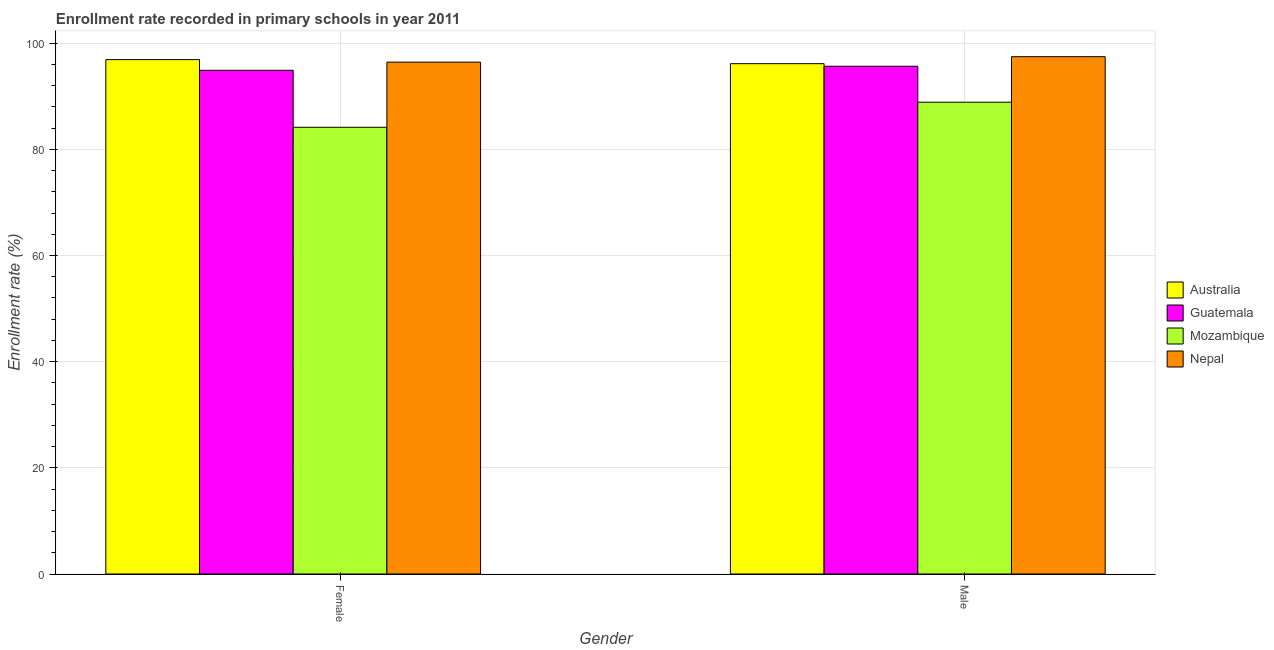How many different coloured bars are there?
Your answer should be compact. 4. How many groups of bars are there?
Provide a short and direct response. 2. How many bars are there on the 1st tick from the left?
Your answer should be compact. 4. How many bars are there on the 1st tick from the right?
Your answer should be very brief. 4. What is the enrollment rate of male students in Australia?
Ensure brevity in your answer.  96.13. Across all countries, what is the maximum enrollment rate of male students?
Your answer should be very brief. 97.45. Across all countries, what is the minimum enrollment rate of male students?
Make the answer very short. 88.87. In which country was the enrollment rate of female students minimum?
Your response must be concise. Mozambique. What is the total enrollment rate of female students in the graph?
Provide a succinct answer. 372.35. What is the difference between the enrollment rate of female students in Guatemala and that in Australia?
Give a very brief answer. -2.01. What is the difference between the enrollment rate of male students in Australia and the enrollment rate of female students in Guatemala?
Keep it short and to the point. 1.25. What is the average enrollment rate of female students per country?
Make the answer very short. 93.09. What is the difference between the enrollment rate of male students and enrollment rate of female students in Nepal?
Provide a short and direct response. 1.02. In how many countries, is the enrollment rate of male students greater than 12 %?
Make the answer very short. 4. What is the ratio of the enrollment rate of female students in Mozambique to that in Guatemala?
Make the answer very short. 0.89. Is the enrollment rate of male students in Nepal less than that in Australia?
Ensure brevity in your answer.  No. What does the 4th bar from the right in Female represents?
Offer a terse response. Australia. How many bars are there?
Your answer should be very brief. 8. Are all the bars in the graph horizontal?
Provide a short and direct response. No. How many countries are there in the graph?
Your answer should be very brief. 4. Does the graph contain grids?
Offer a terse response. Yes. Where does the legend appear in the graph?
Your answer should be very brief. Center right. What is the title of the graph?
Provide a short and direct response. Enrollment rate recorded in primary schools in year 2011. What is the label or title of the Y-axis?
Give a very brief answer. Enrollment rate (%). What is the Enrollment rate (%) in Australia in Female?
Your answer should be compact. 96.89. What is the Enrollment rate (%) in Guatemala in Female?
Offer a terse response. 94.88. What is the Enrollment rate (%) of Mozambique in Female?
Ensure brevity in your answer.  84.15. What is the Enrollment rate (%) in Nepal in Female?
Offer a very short reply. 96.42. What is the Enrollment rate (%) in Australia in Male?
Your answer should be compact. 96.13. What is the Enrollment rate (%) of Guatemala in Male?
Your response must be concise. 95.64. What is the Enrollment rate (%) in Mozambique in Male?
Provide a short and direct response. 88.87. What is the Enrollment rate (%) in Nepal in Male?
Give a very brief answer. 97.45. Across all Gender, what is the maximum Enrollment rate (%) in Australia?
Your answer should be compact. 96.89. Across all Gender, what is the maximum Enrollment rate (%) in Guatemala?
Your response must be concise. 95.64. Across all Gender, what is the maximum Enrollment rate (%) of Mozambique?
Provide a succinct answer. 88.87. Across all Gender, what is the maximum Enrollment rate (%) of Nepal?
Ensure brevity in your answer.  97.45. Across all Gender, what is the minimum Enrollment rate (%) in Australia?
Provide a succinct answer. 96.13. Across all Gender, what is the minimum Enrollment rate (%) in Guatemala?
Provide a short and direct response. 94.88. Across all Gender, what is the minimum Enrollment rate (%) of Mozambique?
Provide a succinct answer. 84.15. Across all Gender, what is the minimum Enrollment rate (%) of Nepal?
Your answer should be compact. 96.42. What is the total Enrollment rate (%) in Australia in the graph?
Your answer should be compact. 193.02. What is the total Enrollment rate (%) in Guatemala in the graph?
Ensure brevity in your answer.  190.53. What is the total Enrollment rate (%) in Mozambique in the graph?
Offer a very short reply. 173.02. What is the total Enrollment rate (%) of Nepal in the graph?
Your response must be concise. 193.87. What is the difference between the Enrollment rate (%) of Australia in Female and that in Male?
Give a very brief answer. 0.76. What is the difference between the Enrollment rate (%) in Guatemala in Female and that in Male?
Make the answer very short. -0.76. What is the difference between the Enrollment rate (%) of Mozambique in Female and that in Male?
Offer a terse response. -4.72. What is the difference between the Enrollment rate (%) of Nepal in Female and that in Male?
Keep it short and to the point. -1.02. What is the difference between the Enrollment rate (%) in Australia in Female and the Enrollment rate (%) in Guatemala in Male?
Your response must be concise. 1.25. What is the difference between the Enrollment rate (%) in Australia in Female and the Enrollment rate (%) in Mozambique in Male?
Offer a very short reply. 8.02. What is the difference between the Enrollment rate (%) in Australia in Female and the Enrollment rate (%) in Nepal in Male?
Give a very brief answer. -0.55. What is the difference between the Enrollment rate (%) of Guatemala in Female and the Enrollment rate (%) of Mozambique in Male?
Offer a very short reply. 6.01. What is the difference between the Enrollment rate (%) in Guatemala in Female and the Enrollment rate (%) in Nepal in Male?
Ensure brevity in your answer.  -2.56. What is the difference between the Enrollment rate (%) of Mozambique in Female and the Enrollment rate (%) of Nepal in Male?
Ensure brevity in your answer.  -13.3. What is the average Enrollment rate (%) of Australia per Gender?
Provide a short and direct response. 96.51. What is the average Enrollment rate (%) of Guatemala per Gender?
Provide a short and direct response. 95.26. What is the average Enrollment rate (%) in Mozambique per Gender?
Provide a succinct answer. 86.51. What is the average Enrollment rate (%) of Nepal per Gender?
Your response must be concise. 96.93. What is the difference between the Enrollment rate (%) of Australia and Enrollment rate (%) of Guatemala in Female?
Provide a succinct answer. 2.01. What is the difference between the Enrollment rate (%) in Australia and Enrollment rate (%) in Mozambique in Female?
Ensure brevity in your answer.  12.74. What is the difference between the Enrollment rate (%) in Australia and Enrollment rate (%) in Nepal in Female?
Offer a very short reply. 0.47. What is the difference between the Enrollment rate (%) in Guatemala and Enrollment rate (%) in Mozambique in Female?
Ensure brevity in your answer.  10.73. What is the difference between the Enrollment rate (%) in Guatemala and Enrollment rate (%) in Nepal in Female?
Ensure brevity in your answer.  -1.54. What is the difference between the Enrollment rate (%) in Mozambique and Enrollment rate (%) in Nepal in Female?
Provide a short and direct response. -12.27. What is the difference between the Enrollment rate (%) of Australia and Enrollment rate (%) of Guatemala in Male?
Ensure brevity in your answer.  0.48. What is the difference between the Enrollment rate (%) in Australia and Enrollment rate (%) in Mozambique in Male?
Offer a very short reply. 7.26. What is the difference between the Enrollment rate (%) in Australia and Enrollment rate (%) in Nepal in Male?
Offer a terse response. -1.32. What is the difference between the Enrollment rate (%) of Guatemala and Enrollment rate (%) of Mozambique in Male?
Give a very brief answer. 6.77. What is the difference between the Enrollment rate (%) in Guatemala and Enrollment rate (%) in Nepal in Male?
Your answer should be compact. -1.8. What is the difference between the Enrollment rate (%) of Mozambique and Enrollment rate (%) of Nepal in Male?
Your answer should be compact. -8.57. What is the ratio of the Enrollment rate (%) of Australia in Female to that in Male?
Offer a terse response. 1.01. What is the ratio of the Enrollment rate (%) in Guatemala in Female to that in Male?
Your response must be concise. 0.99. What is the ratio of the Enrollment rate (%) of Mozambique in Female to that in Male?
Give a very brief answer. 0.95. What is the difference between the highest and the second highest Enrollment rate (%) in Australia?
Give a very brief answer. 0.76. What is the difference between the highest and the second highest Enrollment rate (%) of Guatemala?
Offer a terse response. 0.76. What is the difference between the highest and the second highest Enrollment rate (%) in Mozambique?
Provide a short and direct response. 4.72. What is the difference between the highest and the second highest Enrollment rate (%) in Nepal?
Keep it short and to the point. 1.02. What is the difference between the highest and the lowest Enrollment rate (%) in Australia?
Give a very brief answer. 0.76. What is the difference between the highest and the lowest Enrollment rate (%) of Guatemala?
Ensure brevity in your answer.  0.76. What is the difference between the highest and the lowest Enrollment rate (%) of Mozambique?
Provide a succinct answer. 4.72. What is the difference between the highest and the lowest Enrollment rate (%) of Nepal?
Make the answer very short. 1.02. 